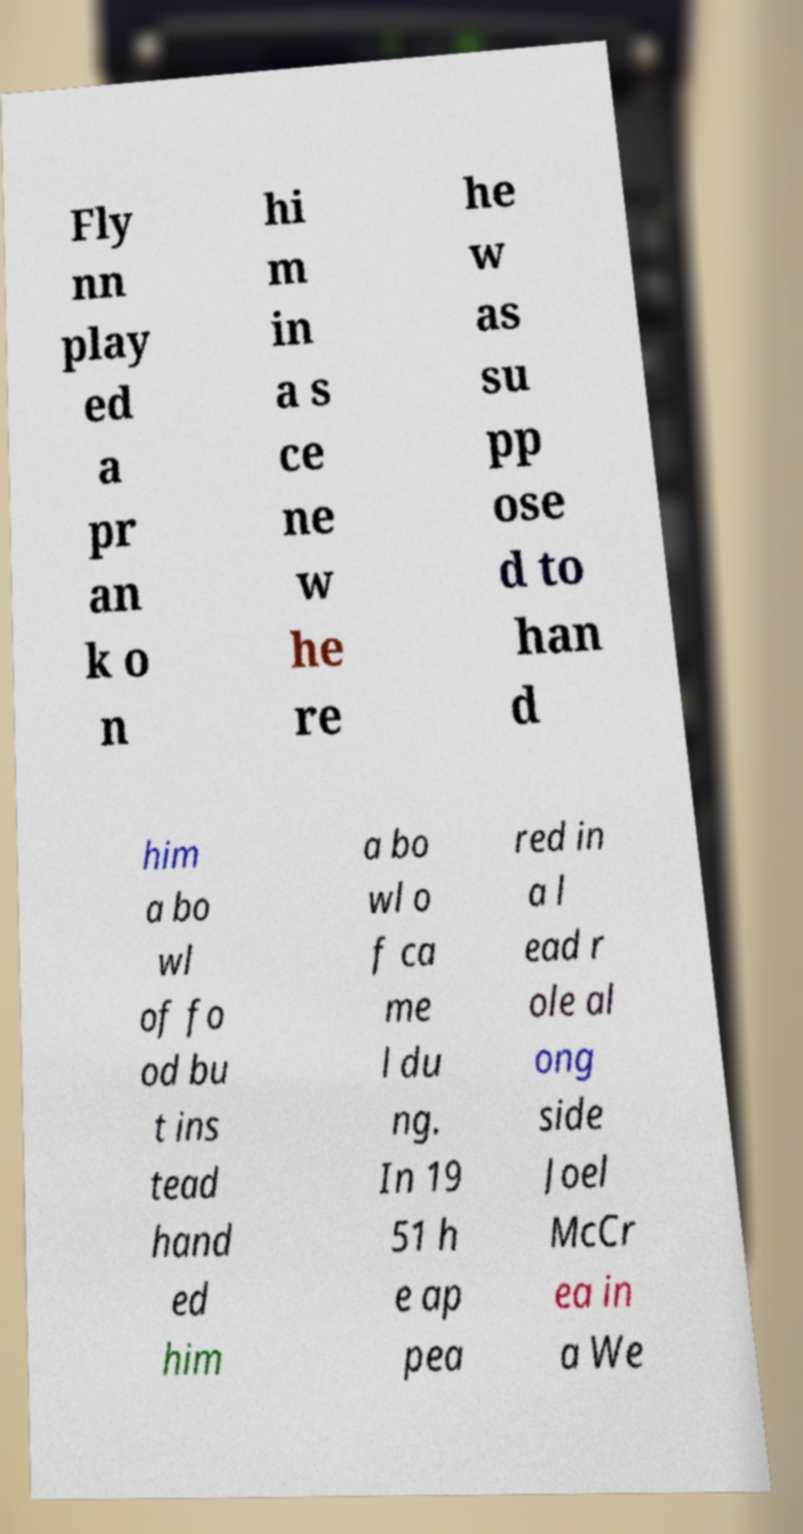Can you read and provide the text displayed in the image?This photo seems to have some interesting text. Can you extract and type it out for me? Fly nn play ed a pr an k o n hi m in a s ce ne w he re he w as su pp ose d to han d him a bo wl of fo od bu t ins tead hand ed him a bo wl o f ca me l du ng. In 19 51 h e ap pea red in a l ead r ole al ong side Joel McCr ea in a We 